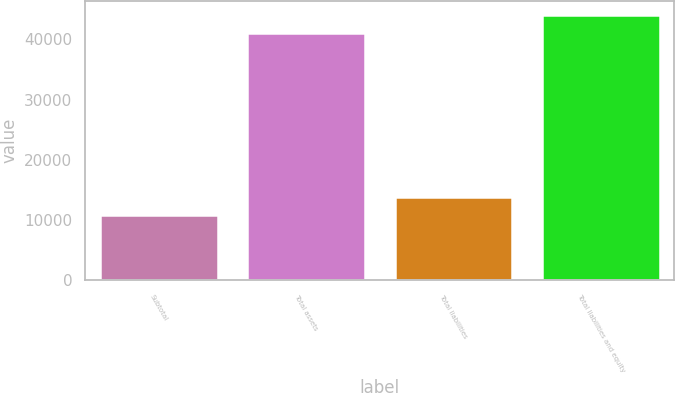Convert chart. <chart><loc_0><loc_0><loc_500><loc_500><bar_chart><fcel>Subtotal<fcel>Total assets<fcel>Total liabilities<fcel>Total liabilities and equity<nl><fcel>10775<fcel>41080<fcel>13805.5<fcel>44110.5<nl></chart> 